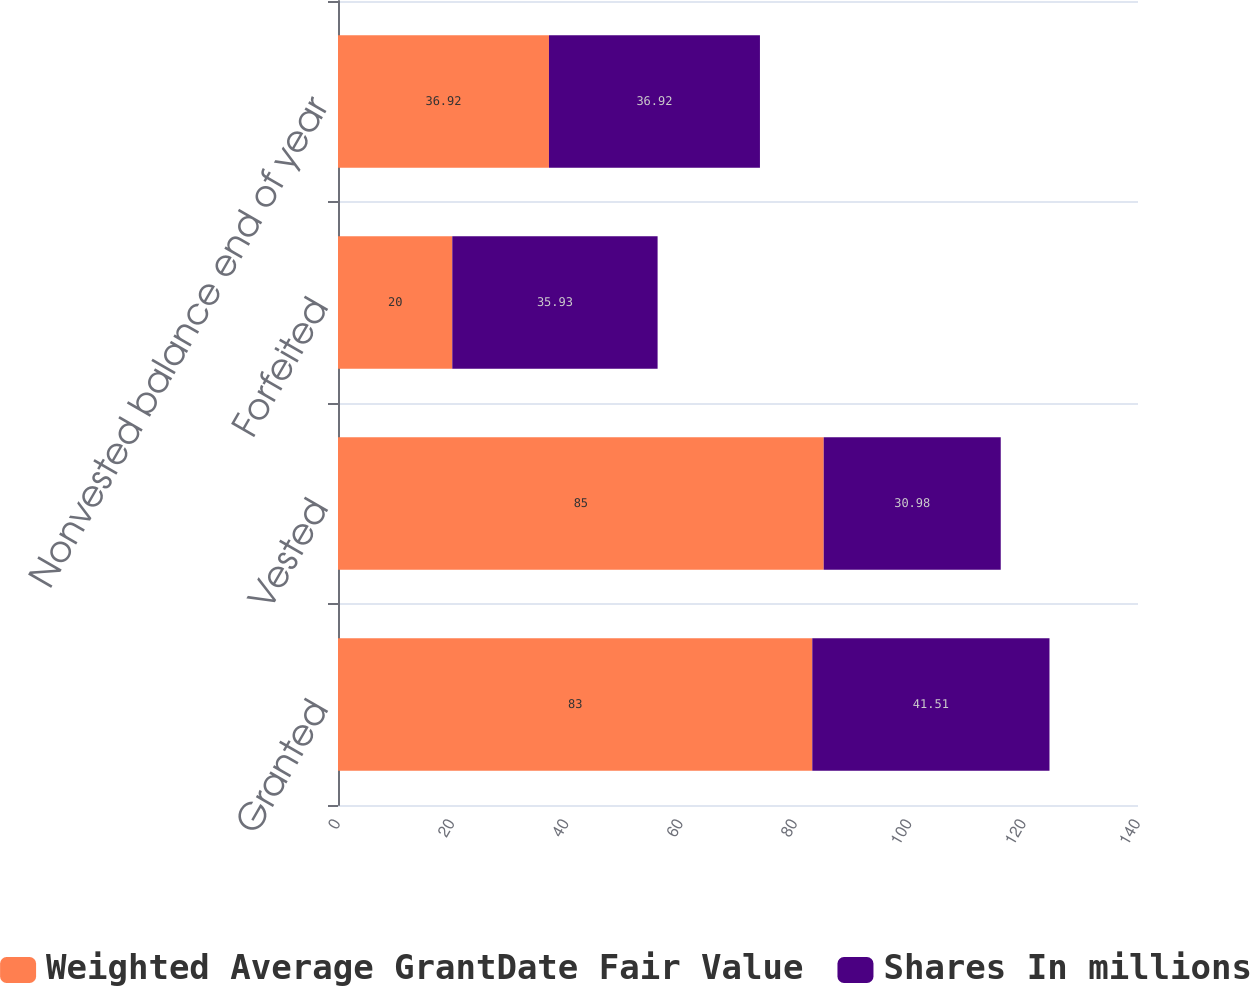Convert chart to OTSL. <chart><loc_0><loc_0><loc_500><loc_500><stacked_bar_chart><ecel><fcel>Granted<fcel>Vested<fcel>Forfeited<fcel>Nonvested balance end of year<nl><fcel>Weighted Average GrantDate Fair Value<fcel>83<fcel>85<fcel>20<fcel>36.92<nl><fcel>Shares In millions<fcel>41.51<fcel>30.98<fcel>35.93<fcel>36.92<nl></chart> 